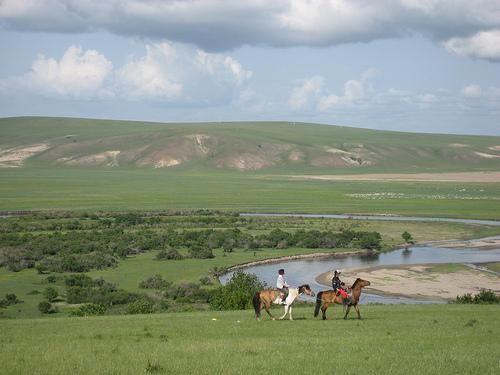What word would best describe their movement? walking 